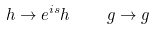<formula> <loc_0><loc_0><loc_500><loc_500>h \rightarrow e ^ { i s } h \quad g \rightarrow g</formula> 